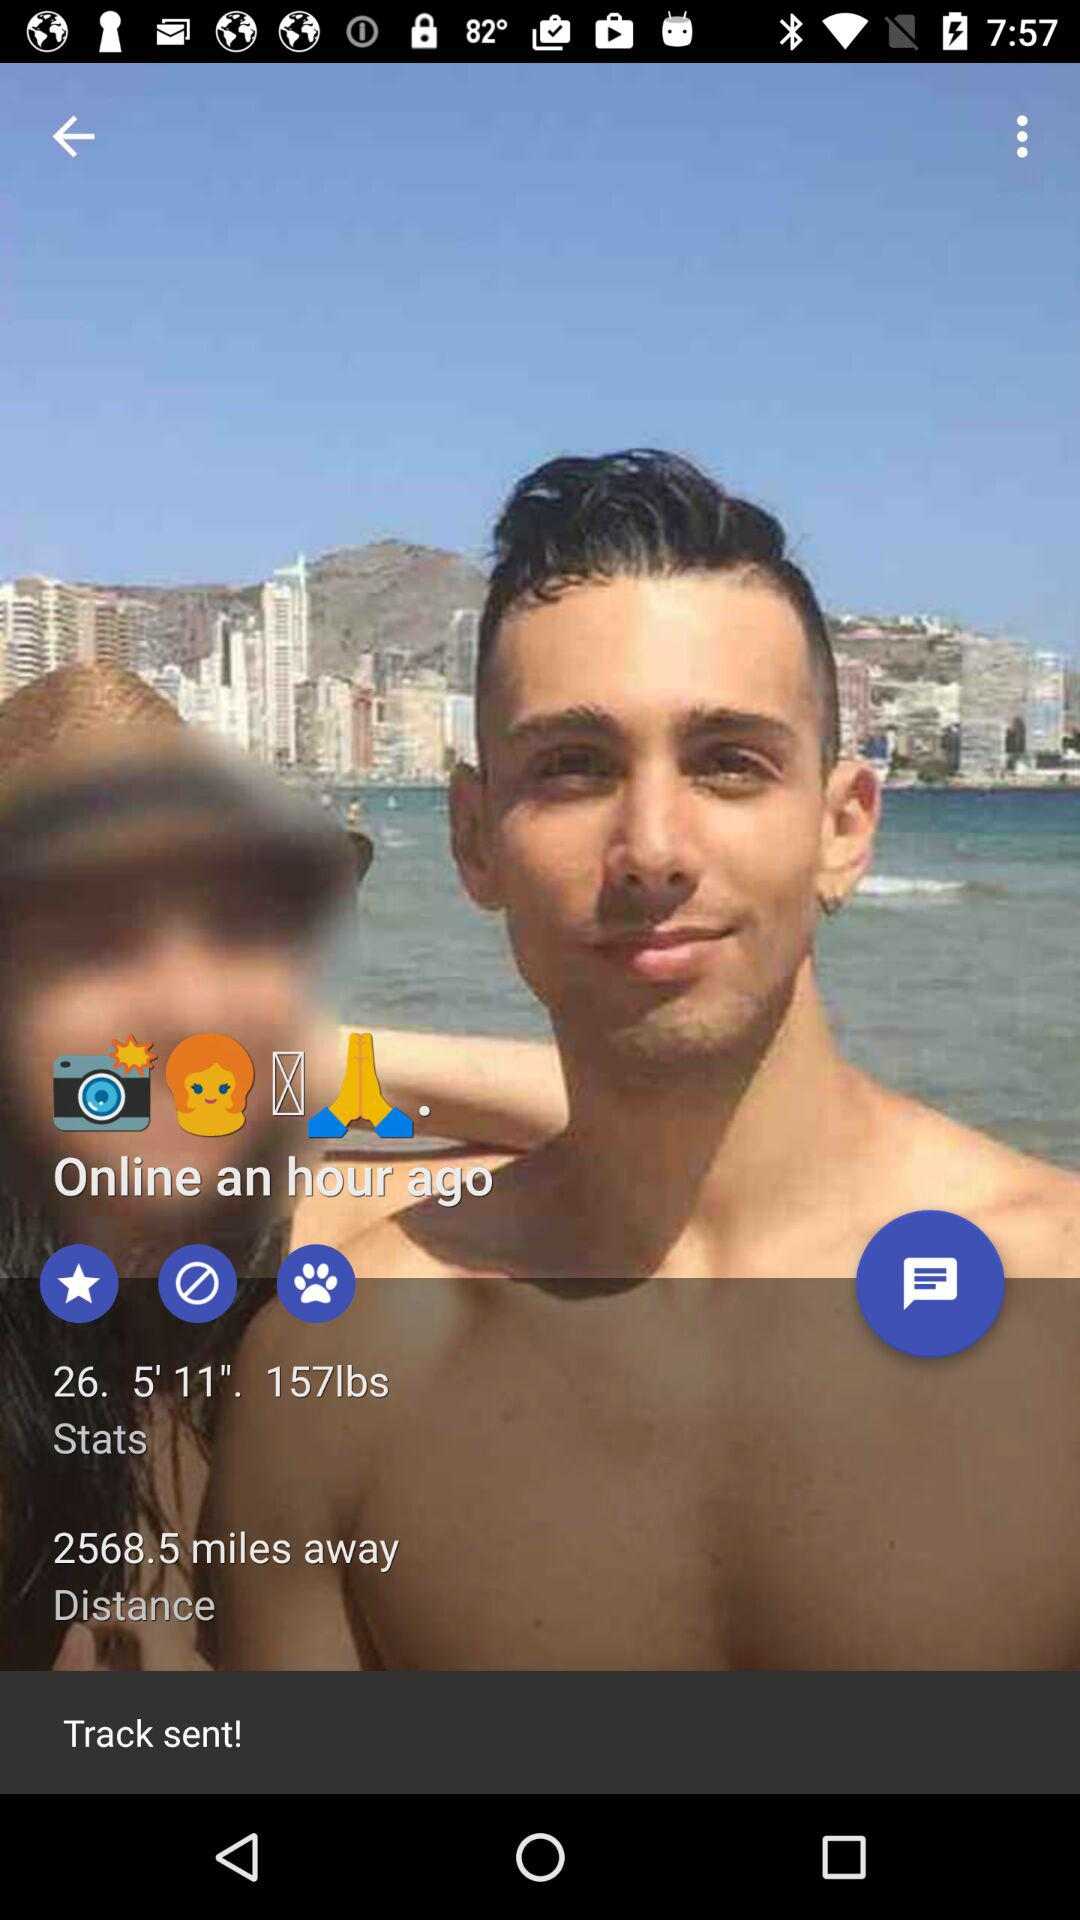What is the weight? The weight is 157 lbs. 